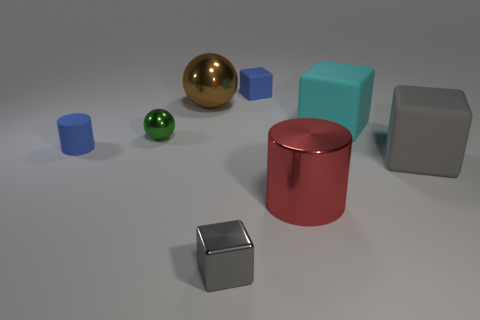Subtract all large cyan cubes. How many cubes are left? 3 Add 2 cyan objects. How many objects exist? 10 Subtract all green spheres. How many gray blocks are left? 2 Subtract all cylinders. How many objects are left? 6 Subtract all brown spheres. How many spheres are left? 1 Subtract 0 cyan cylinders. How many objects are left? 8 Subtract 1 spheres. How many spheres are left? 1 Subtract all cyan cubes. Subtract all green cylinders. How many cubes are left? 3 Subtract all small matte cylinders. Subtract all tiny yellow cylinders. How many objects are left? 7 Add 3 tiny blue rubber things. How many tiny blue rubber things are left? 5 